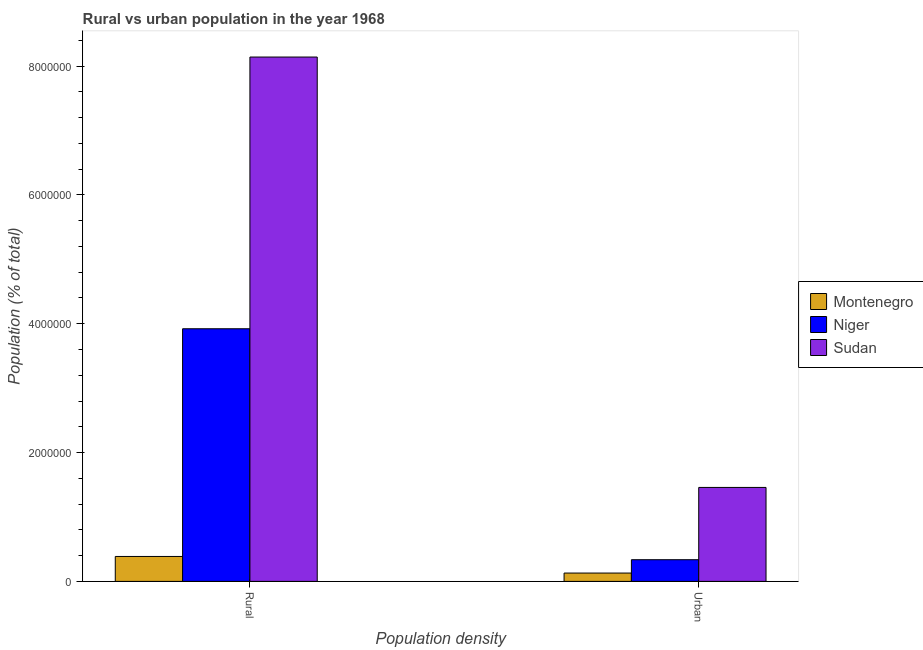Are the number of bars on each tick of the X-axis equal?
Ensure brevity in your answer.  Yes. What is the label of the 1st group of bars from the left?
Provide a succinct answer. Rural. What is the urban population density in Montenegro?
Make the answer very short. 1.30e+05. Across all countries, what is the maximum urban population density?
Ensure brevity in your answer.  1.46e+06. Across all countries, what is the minimum urban population density?
Give a very brief answer. 1.30e+05. In which country was the rural population density maximum?
Provide a succinct answer. Sudan. In which country was the rural population density minimum?
Offer a very short reply. Montenegro. What is the total rural population density in the graph?
Ensure brevity in your answer.  1.24e+07. What is the difference between the urban population density in Montenegro and that in Sudan?
Make the answer very short. -1.33e+06. What is the difference between the rural population density in Sudan and the urban population density in Montenegro?
Offer a terse response. 8.01e+06. What is the average rural population density per country?
Your response must be concise. 4.15e+06. What is the difference between the rural population density and urban population density in Sudan?
Your answer should be compact. 6.68e+06. In how many countries, is the rural population density greater than 2000000 %?
Provide a short and direct response. 2. What is the ratio of the rural population density in Niger to that in Montenegro?
Your response must be concise. 10.13. In how many countries, is the urban population density greater than the average urban population density taken over all countries?
Offer a very short reply. 1. What does the 2nd bar from the left in Urban represents?
Provide a short and direct response. Niger. What does the 3rd bar from the right in Rural represents?
Keep it short and to the point. Montenegro. How many countries are there in the graph?
Keep it short and to the point. 3. How are the legend labels stacked?
Give a very brief answer. Vertical. What is the title of the graph?
Your answer should be compact. Rural vs urban population in the year 1968. Does "Sub-Saharan Africa (all income levels)" appear as one of the legend labels in the graph?
Your response must be concise. No. What is the label or title of the X-axis?
Your answer should be compact. Population density. What is the label or title of the Y-axis?
Ensure brevity in your answer.  Population (% of total). What is the Population (% of total) in Montenegro in Rural?
Your answer should be very brief. 3.87e+05. What is the Population (% of total) of Niger in Rural?
Your response must be concise. 3.92e+06. What is the Population (% of total) in Sudan in Rural?
Ensure brevity in your answer.  8.14e+06. What is the Population (% of total) in Montenegro in Urban?
Provide a short and direct response. 1.30e+05. What is the Population (% of total) of Niger in Urban?
Make the answer very short. 3.37e+05. What is the Population (% of total) of Sudan in Urban?
Give a very brief answer. 1.46e+06. Across all Population density, what is the maximum Population (% of total) of Montenegro?
Your answer should be compact. 3.87e+05. Across all Population density, what is the maximum Population (% of total) in Niger?
Your answer should be compact. 3.92e+06. Across all Population density, what is the maximum Population (% of total) of Sudan?
Your response must be concise. 8.14e+06. Across all Population density, what is the minimum Population (% of total) of Montenegro?
Ensure brevity in your answer.  1.30e+05. Across all Population density, what is the minimum Population (% of total) of Niger?
Offer a terse response. 3.37e+05. Across all Population density, what is the minimum Population (% of total) of Sudan?
Provide a succinct answer. 1.46e+06. What is the total Population (% of total) of Montenegro in the graph?
Keep it short and to the point. 5.17e+05. What is the total Population (% of total) of Niger in the graph?
Ensure brevity in your answer.  4.26e+06. What is the total Population (% of total) in Sudan in the graph?
Your response must be concise. 9.60e+06. What is the difference between the Population (% of total) in Montenegro in Rural and that in Urban?
Ensure brevity in your answer.  2.57e+05. What is the difference between the Population (% of total) of Niger in Rural and that in Urban?
Your answer should be compact. 3.59e+06. What is the difference between the Population (% of total) in Sudan in Rural and that in Urban?
Make the answer very short. 6.68e+06. What is the difference between the Population (% of total) of Montenegro in Rural and the Population (% of total) of Niger in Urban?
Provide a short and direct response. 5.04e+04. What is the difference between the Population (% of total) of Montenegro in Rural and the Population (% of total) of Sudan in Urban?
Your answer should be compact. -1.07e+06. What is the difference between the Population (% of total) of Niger in Rural and the Population (% of total) of Sudan in Urban?
Provide a short and direct response. 2.46e+06. What is the average Population (% of total) of Montenegro per Population density?
Provide a succinct answer. 2.58e+05. What is the average Population (% of total) in Niger per Population density?
Offer a terse response. 2.13e+06. What is the average Population (% of total) in Sudan per Population density?
Your answer should be compact. 4.80e+06. What is the difference between the Population (% of total) in Montenegro and Population (% of total) in Niger in Rural?
Keep it short and to the point. -3.53e+06. What is the difference between the Population (% of total) in Montenegro and Population (% of total) in Sudan in Rural?
Your response must be concise. -7.75e+06. What is the difference between the Population (% of total) of Niger and Population (% of total) of Sudan in Rural?
Provide a short and direct response. -4.22e+06. What is the difference between the Population (% of total) in Montenegro and Population (% of total) in Niger in Urban?
Give a very brief answer. -2.07e+05. What is the difference between the Population (% of total) in Montenegro and Population (% of total) in Sudan in Urban?
Give a very brief answer. -1.33e+06. What is the difference between the Population (% of total) of Niger and Population (% of total) of Sudan in Urban?
Provide a succinct answer. -1.12e+06. What is the ratio of the Population (% of total) in Montenegro in Rural to that in Urban?
Give a very brief answer. 2.99. What is the ratio of the Population (% of total) in Niger in Rural to that in Urban?
Provide a succinct answer. 11.65. What is the ratio of the Population (% of total) in Sudan in Rural to that in Urban?
Keep it short and to the point. 5.58. What is the difference between the highest and the second highest Population (% of total) in Montenegro?
Give a very brief answer. 2.57e+05. What is the difference between the highest and the second highest Population (% of total) in Niger?
Provide a succinct answer. 3.59e+06. What is the difference between the highest and the second highest Population (% of total) of Sudan?
Your answer should be very brief. 6.68e+06. What is the difference between the highest and the lowest Population (% of total) of Montenegro?
Your answer should be compact. 2.57e+05. What is the difference between the highest and the lowest Population (% of total) in Niger?
Your answer should be compact. 3.59e+06. What is the difference between the highest and the lowest Population (% of total) of Sudan?
Your answer should be compact. 6.68e+06. 